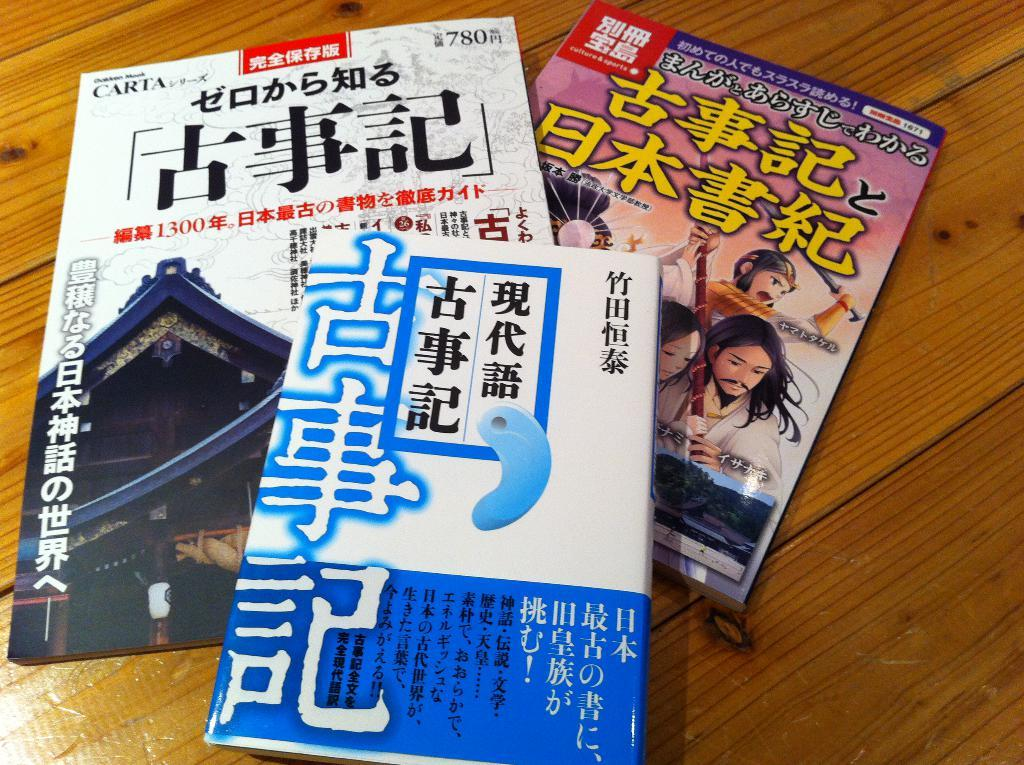<image>
Present a compact description of the photo's key features. The numbers 1300 and 780 written on the cover of a Japanese Magazine. 